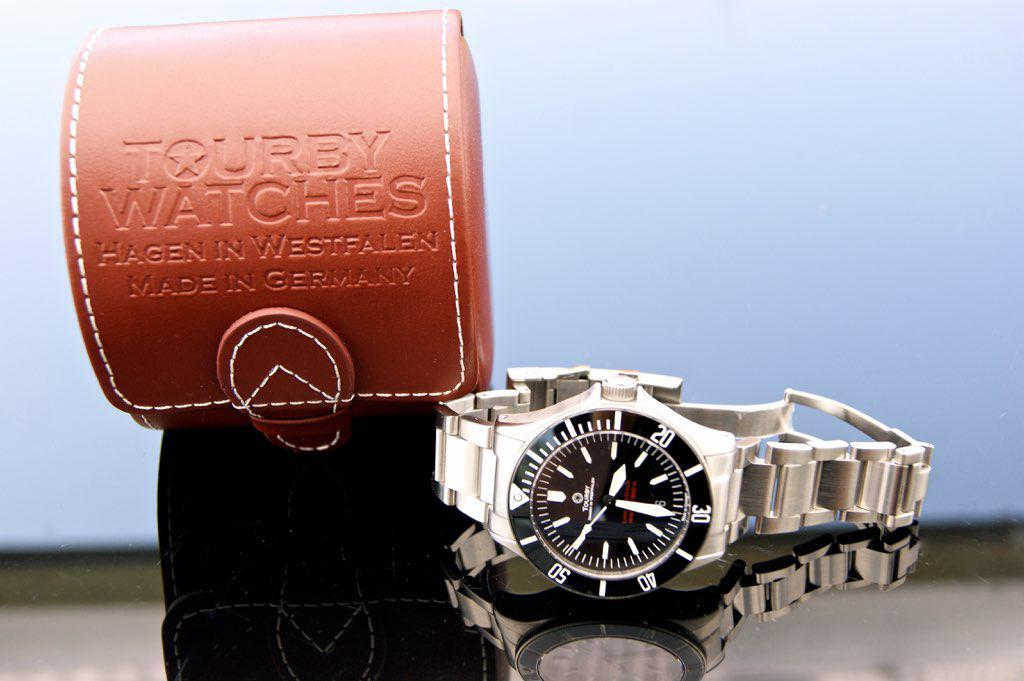<image>
Give a short and clear explanation of the subsequent image. Watch laying on the side next to the Tourby Watch case 